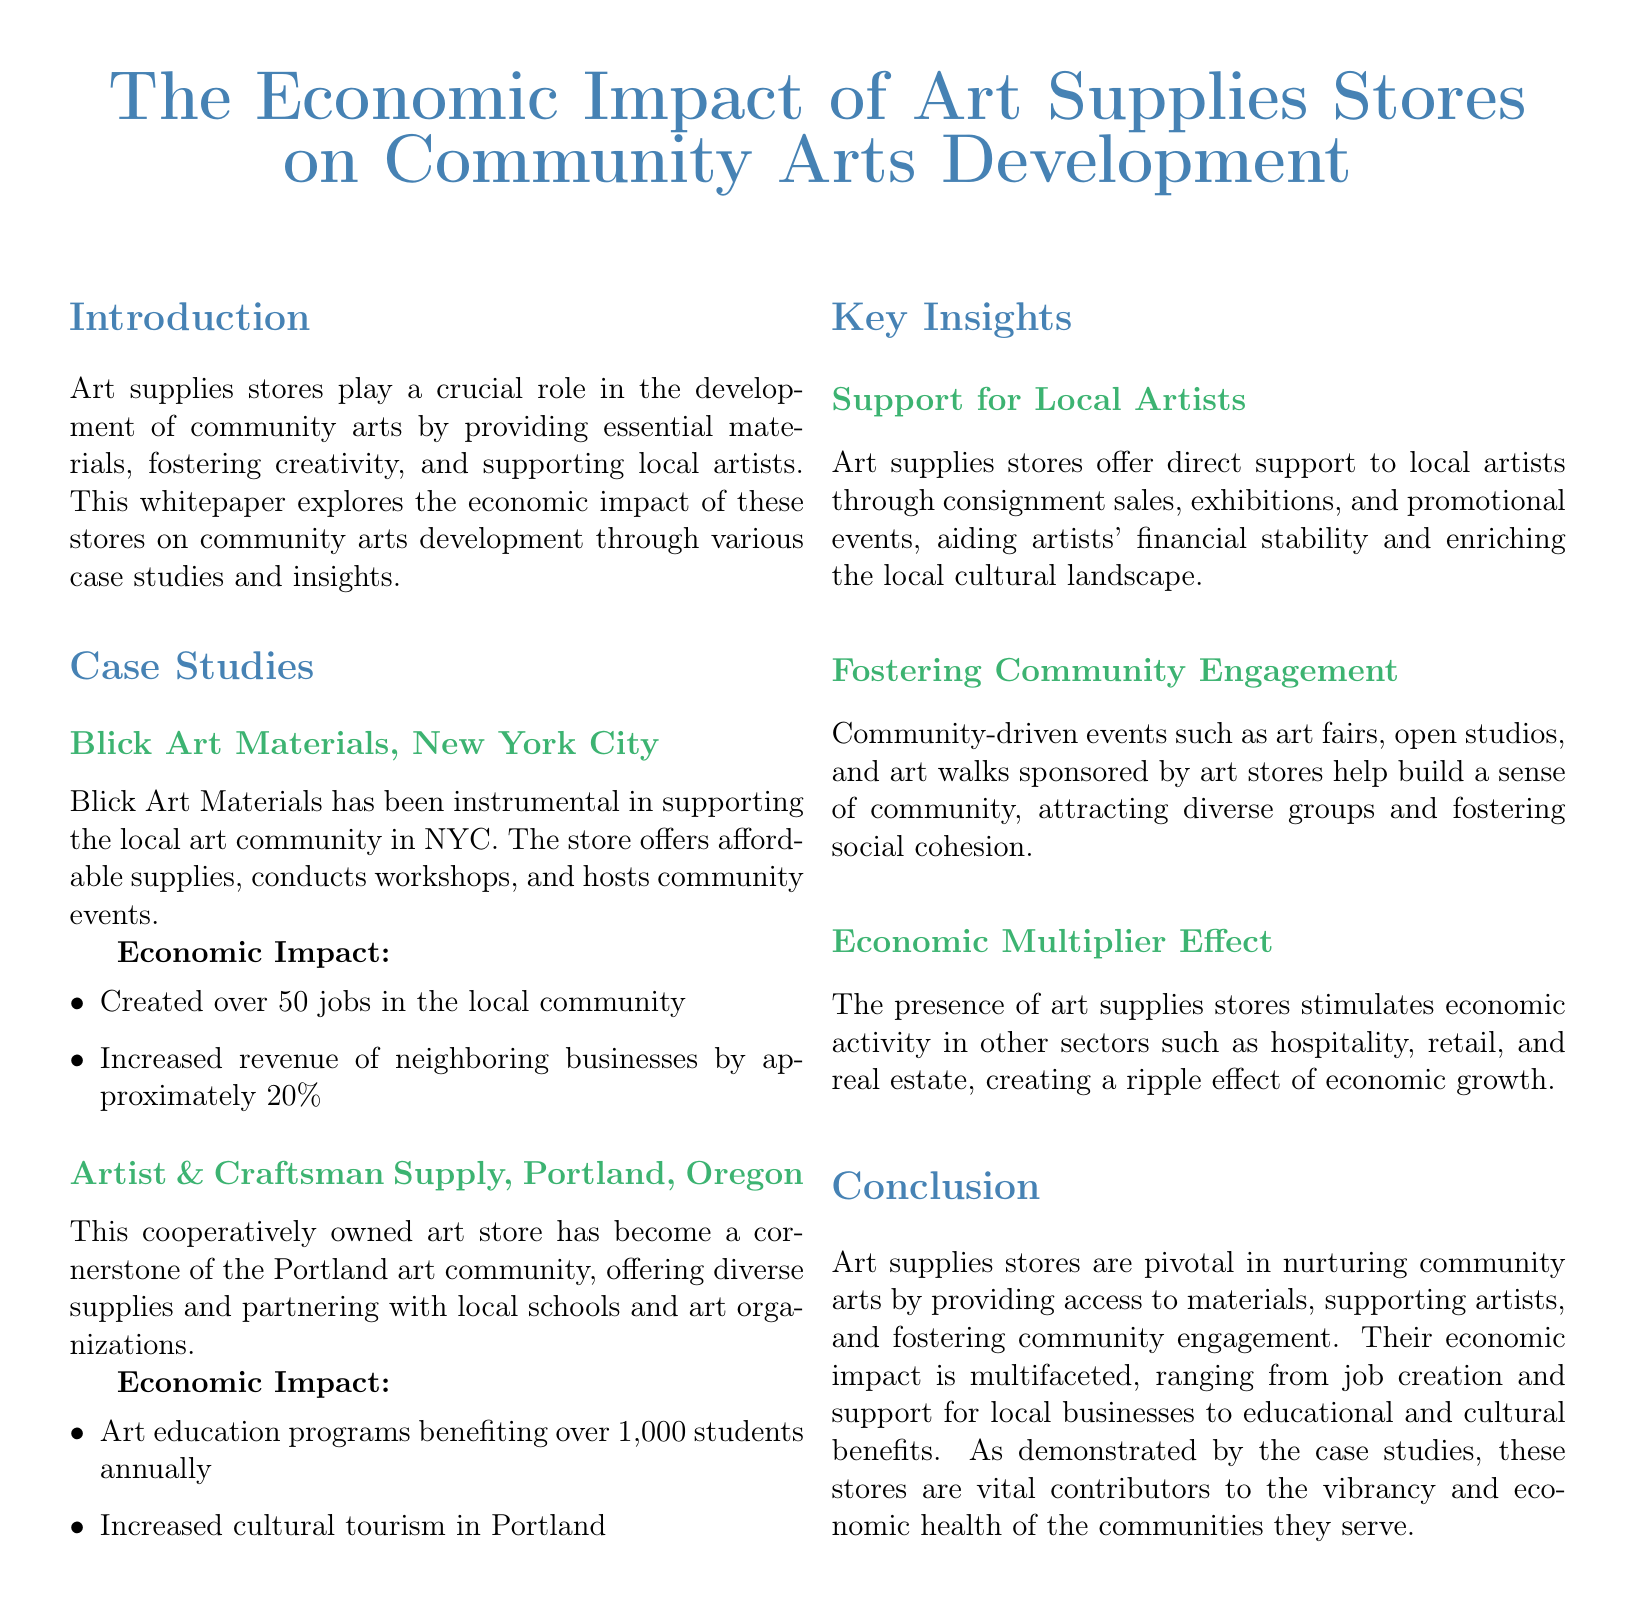what is the title of the whitepaper? The title is prominently displayed at the beginning of the document.
Answer: The Economic Impact of Art Supplies Stores on Community Arts Development which store is mentioned as supporting local artists in New York City? The case studies section lists specific stores and their locations.
Answer: Blick Art Materials how many jobs did Blick Art Materials create in the local community? The economic impact section for Blick Art Materials includes specific job creation statistics.
Answer: over 50 jobs how many students benefit annually from art education programs at Artist & Craftsman Supply? This information is detailed in the economic impact section for the Portland store.
Answer: over 1,000 students what type of events do art supplies stores sponsor to foster community engagement? The key insights section discusses community-driven initiatives sponsored by art stores.
Answer: art fairs, open studios, and art walks what is the economic effect referred to in the document regarding art supplies stores? This is described in a section discussing broader economic impacts associated with art supplies stores.
Answer: Economic Multiplier Effect which city is mentioned in relation to increased cultural tourism due to a local art store? The economic impact section for Artist & Craftsman Supply indicates the city related to tourism benefits.
Answer: Portland what role do art supplies stores play in the local cultural landscape? The key insights section details the contributions of art supplies stores to local culture and artists.
Answer: support for local artists 